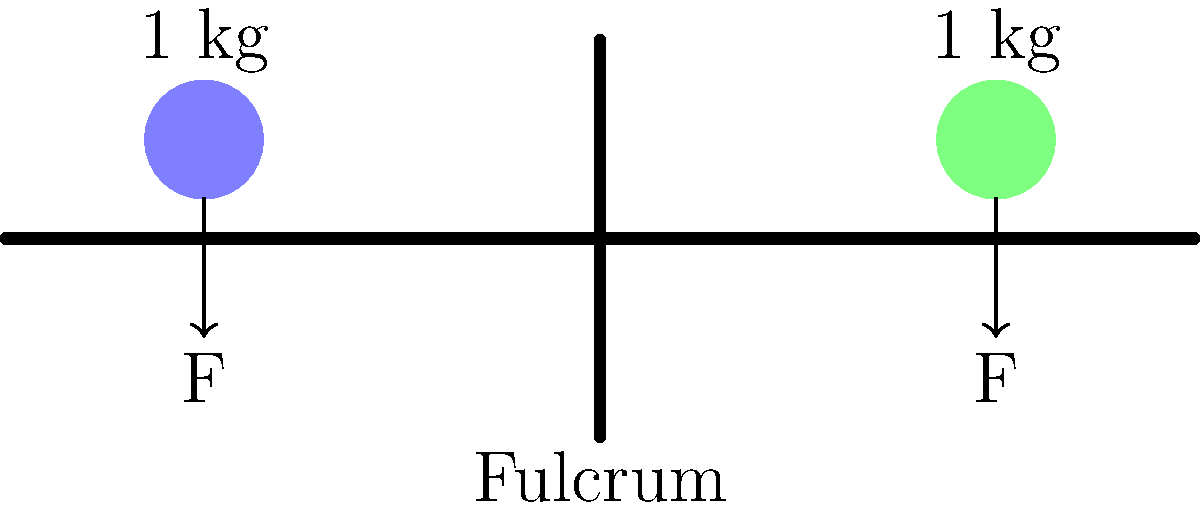Look at the seesaw in the picture. Two friends, each weighing 1 kg, sit on opposite ends. The seesaw is perfectly balanced. What can you say about the forces acting on each side of the seesaw? Let's think about this step-by-step:

1. We see a seesaw with two friends sitting on it, one on each end.
2. Both friends weigh the same (1 kg each).
3. The seesaw is balanced, which means it's not tipping to either side.
4. The middle point of the seesaw is called the fulcrum. This is where the seesaw balances.
5. Each friend creates a downward force due to their weight.
6. Since both friends weigh the same and are at equal distances from the fulcrum, their forces are equal.
7. When the forces on both sides are equal, the seesaw stays balanced.
8. In the diagram, we can see arrows pointing down on both sides. These represent the equal forces.

So, we can conclude that the forces acting on each side of the seesaw are equal.
Answer: The forces are equal on both sides. 